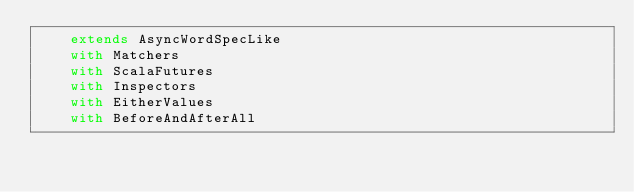<code> <loc_0><loc_0><loc_500><loc_500><_Scala_>    extends AsyncWordSpecLike
    with Matchers
    with ScalaFutures
    with Inspectors
    with EitherValues
    with BeforeAndAfterAll
</code> 